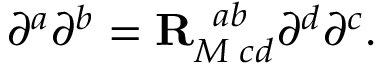<formula> <loc_0><loc_0><loc_500><loc_500>\partial ^ { a } \partial ^ { b } = { R } _ { M \, c d } ^ { \, a b } \partial ^ { d } \partial ^ { c } .</formula> 